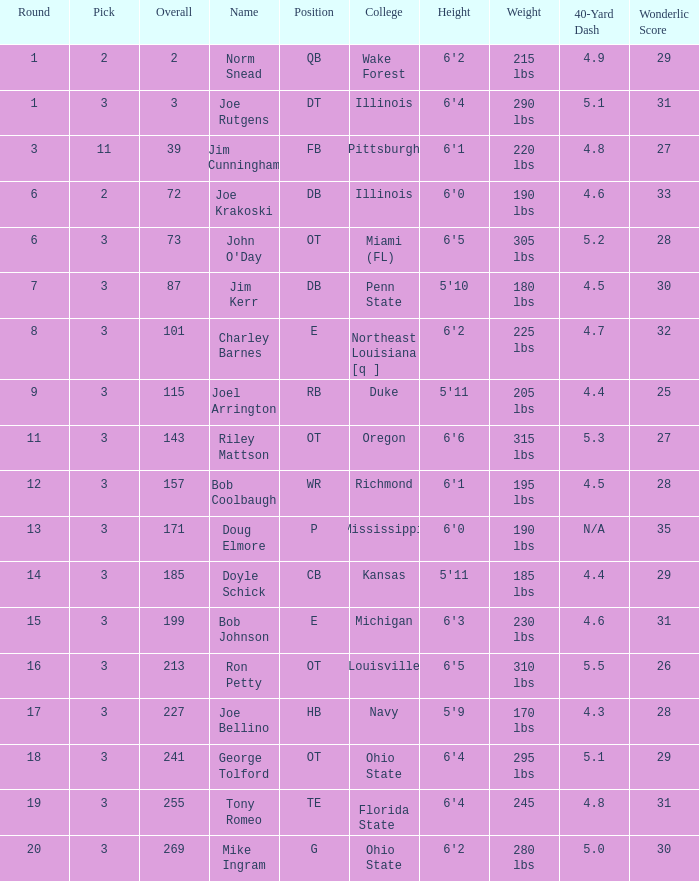How many overalls have charley barnes as the name, with a pick less than 3? None. 